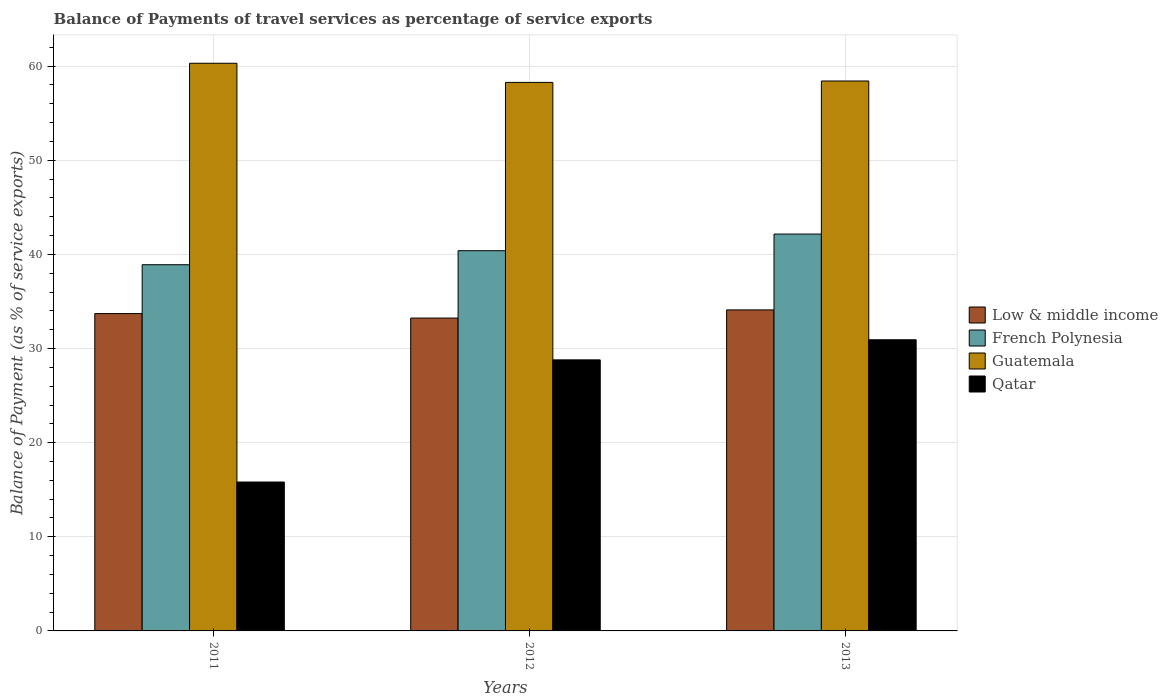How many groups of bars are there?
Provide a short and direct response. 3. How many bars are there on the 2nd tick from the left?
Offer a terse response. 4. What is the balance of payments of travel services in Guatemala in 2013?
Your response must be concise. 58.42. Across all years, what is the maximum balance of payments of travel services in Low & middle income?
Your answer should be very brief. 34.1. Across all years, what is the minimum balance of payments of travel services in Low & middle income?
Your response must be concise. 33.23. In which year was the balance of payments of travel services in Guatemala minimum?
Offer a very short reply. 2012. What is the total balance of payments of travel services in French Polynesia in the graph?
Provide a short and direct response. 121.45. What is the difference between the balance of payments of travel services in Low & middle income in 2011 and that in 2013?
Your response must be concise. -0.39. What is the difference between the balance of payments of travel services in Low & middle income in 2011 and the balance of payments of travel services in French Polynesia in 2012?
Offer a very short reply. -6.68. What is the average balance of payments of travel services in Qatar per year?
Ensure brevity in your answer.  25.18. In the year 2013, what is the difference between the balance of payments of travel services in French Polynesia and balance of payments of travel services in Low & middle income?
Your answer should be compact. 8.06. What is the ratio of the balance of payments of travel services in Qatar in 2011 to that in 2012?
Keep it short and to the point. 0.55. Is the balance of payments of travel services in Qatar in 2011 less than that in 2013?
Your answer should be compact. Yes. What is the difference between the highest and the second highest balance of payments of travel services in Qatar?
Offer a very short reply. 2.14. What is the difference between the highest and the lowest balance of payments of travel services in French Polynesia?
Ensure brevity in your answer.  3.26. In how many years, is the balance of payments of travel services in Qatar greater than the average balance of payments of travel services in Qatar taken over all years?
Your answer should be very brief. 2. Is the sum of the balance of payments of travel services in Low & middle income in 2012 and 2013 greater than the maximum balance of payments of travel services in Guatemala across all years?
Offer a terse response. Yes. What does the 1st bar from the left in 2012 represents?
Your answer should be very brief. Low & middle income. Is it the case that in every year, the sum of the balance of payments of travel services in French Polynesia and balance of payments of travel services in Qatar is greater than the balance of payments of travel services in Guatemala?
Provide a short and direct response. No. Are the values on the major ticks of Y-axis written in scientific E-notation?
Provide a short and direct response. No. Does the graph contain grids?
Provide a short and direct response. Yes. Where does the legend appear in the graph?
Your answer should be very brief. Center right. What is the title of the graph?
Make the answer very short. Balance of Payments of travel services as percentage of service exports. Does "East Asia (all income levels)" appear as one of the legend labels in the graph?
Offer a terse response. No. What is the label or title of the X-axis?
Your response must be concise. Years. What is the label or title of the Y-axis?
Make the answer very short. Balance of Payment (as % of service exports). What is the Balance of Payment (as % of service exports) in Low & middle income in 2011?
Your answer should be compact. 33.71. What is the Balance of Payment (as % of service exports) of French Polynesia in 2011?
Offer a very short reply. 38.9. What is the Balance of Payment (as % of service exports) of Guatemala in 2011?
Give a very brief answer. 60.31. What is the Balance of Payment (as % of service exports) of Qatar in 2011?
Ensure brevity in your answer.  15.82. What is the Balance of Payment (as % of service exports) of Low & middle income in 2012?
Provide a succinct answer. 33.23. What is the Balance of Payment (as % of service exports) in French Polynesia in 2012?
Provide a short and direct response. 40.39. What is the Balance of Payment (as % of service exports) of Guatemala in 2012?
Provide a succinct answer. 58.27. What is the Balance of Payment (as % of service exports) of Qatar in 2012?
Provide a succinct answer. 28.8. What is the Balance of Payment (as % of service exports) of Low & middle income in 2013?
Provide a short and direct response. 34.1. What is the Balance of Payment (as % of service exports) in French Polynesia in 2013?
Make the answer very short. 42.16. What is the Balance of Payment (as % of service exports) of Guatemala in 2013?
Offer a very short reply. 58.42. What is the Balance of Payment (as % of service exports) in Qatar in 2013?
Give a very brief answer. 30.93. Across all years, what is the maximum Balance of Payment (as % of service exports) in Low & middle income?
Provide a succinct answer. 34.1. Across all years, what is the maximum Balance of Payment (as % of service exports) of French Polynesia?
Offer a terse response. 42.16. Across all years, what is the maximum Balance of Payment (as % of service exports) of Guatemala?
Ensure brevity in your answer.  60.31. Across all years, what is the maximum Balance of Payment (as % of service exports) of Qatar?
Your answer should be very brief. 30.93. Across all years, what is the minimum Balance of Payment (as % of service exports) in Low & middle income?
Your answer should be compact. 33.23. Across all years, what is the minimum Balance of Payment (as % of service exports) in French Polynesia?
Keep it short and to the point. 38.9. Across all years, what is the minimum Balance of Payment (as % of service exports) in Guatemala?
Your response must be concise. 58.27. Across all years, what is the minimum Balance of Payment (as % of service exports) of Qatar?
Keep it short and to the point. 15.82. What is the total Balance of Payment (as % of service exports) in Low & middle income in the graph?
Your response must be concise. 101.05. What is the total Balance of Payment (as % of service exports) of French Polynesia in the graph?
Offer a very short reply. 121.45. What is the total Balance of Payment (as % of service exports) of Guatemala in the graph?
Make the answer very short. 177. What is the total Balance of Payment (as % of service exports) of Qatar in the graph?
Your answer should be compact. 75.54. What is the difference between the Balance of Payment (as % of service exports) in Low & middle income in 2011 and that in 2012?
Offer a very short reply. 0.48. What is the difference between the Balance of Payment (as % of service exports) of French Polynesia in 2011 and that in 2012?
Offer a very short reply. -1.49. What is the difference between the Balance of Payment (as % of service exports) of Guatemala in 2011 and that in 2012?
Make the answer very short. 2.03. What is the difference between the Balance of Payment (as % of service exports) of Qatar in 2011 and that in 2012?
Provide a short and direct response. -12.98. What is the difference between the Balance of Payment (as % of service exports) in Low & middle income in 2011 and that in 2013?
Give a very brief answer. -0.39. What is the difference between the Balance of Payment (as % of service exports) in French Polynesia in 2011 and that in 2013?
Your answer should be very brief. -3.26. What is the difference between the Balance of Payment (as % of service exports) of Guatemala in 2011 and that in 2013?
Your response must be concise. 1.88. What is the difference between the Balance of Payment (as % of service exports) in Qatar in 2011 and that in 2013?
Keep it short and to the point. -15.11. What is the difference between the Balance of Payment (as % of service exports) in Low & middle income in 2012 and that in 2013?
Make the answer very short. -0.87. What is the difference between the Balance of Payment (as % of service exports) in French Polynesia in 2012 and that in 2013?
Your answer should be compact. -1.77. What is the difference between the Balance of Payment (as % of service exports) of Guatemala in 2012 and that in 2013?
Offer a very short reply. -0.15. What is the difference between the Balance of Payment (as % of service exports) of Qatar in 2012 and that in 2013?
Ensure brevity in your answer.  -2.14. What is the difference between the Balance of Payment (as % of service exports) in Low & middle income in 2011 and the Balance of Payment (as % of service exports) in French Polynesia in 2012?
Offer a terse response. -6.68. What is the difference between the Balance of Payment (as % of service exports) of Low & middle income in 2011 and the Balance of Payment (as % of service exports) of Guatemala in 2012?
Your answer should be compact. -24.56. What is the difference between the Balance of Payment (as % of service exports) in Low & middle income in 2011 and the Balance of Payment (as % of service exports) in Qatar in 2012?
Ensure brevity in your answer.  4.92. What is the difference between the Balance of Payment (as % of service exports) of French Polynesia in 2011 and the Balance of Payment (as % of service exports) of Guatemala in 2012?
Make the answer very short. -19.37. What is the difference between the Balance of Payment (as % of service exports) in French Polynesia in 2011 and the Balance of Payment (as % of service exports) in Qatar in 2012?
Offer a terse response. 10.11. What is the difference between the Balance of Payment (as % of service exports) of Guatemala in 2011 and the Balance of Payment (as % of service exports) of Qatar in 2012?
Offer a very short reply. 31.51. What is the difference between the Balance of Payment (as % of service exports) of Low & middle income in 2011 and the Balance of Payment (as % of service exports) of French Polynesia in 2013?
Your answer should be compact. -8.45. What is the difference between the Balance of Payment (as % of service exports) of Low & middle income in 2011 and the Balance of Payment (as % of service exports) of Guatemala in 2013?
Your answer should be compact. -24.71. What is the difference between the Balance of Payment (as % of service exports) in Low & middle income in 2011 and the Balance of Payment (as % of service exports) in Qatar in 2013?
Make the answer very short. 2.78. What is the difference between the Balance of Payment (as % of service exports) in French Polynesia in 2011 and the Balance of Payment (as % of service exports) in Guatemala in 2013?
Offer a terse response. -19.52. What is the difference between the Balance of Payment (as % of service exports) of French Polynesia in 2011 and the Balance of Payment (as % of service exports) of Qatar in 2013?
Offer a very short reply. 7.97. What is the difference between the Balance of Payment (as % of service exports) of Guatemala in 2011 and the Balance of Payment (as % of service exports) of Qatar in 2013?
Your response must be concise. 29.37. What is the difference between the Balance of Payment (as % of service exports) in Low & middle income in 2012 and the Balance of Payment (as % of service exports) in French Polynesia in 2013?
Make the answer very short. -8.92. What is the difference between the Balance of Payment (as % of service exports) in Low & middle income in 2012 and the Balance of Payment (as % of service exports) in Guatemala in 2013?
Provide a short and direct response. -25.19. What is the difference between the Balance of Payment (as % of service exports) of Low & middle income in 2012 and the Balance of Payment (as % of service exports) of Qatar in 2013?
Your answer should be compact. 2.3. What is the difference between the Balance of Payment (as % of service exports) of French Polynesia in 2012 and the Balance of Payment (as % of service exports) of Guatemala in 2013?
Offer a terse response. -18.03. What is the difference between the Balance of Payment (as % of service exports) in French Polynesia in 2012 and the Balance of Payment (as % of service exports) in Qatar in 2013?
Keep it short and to the point. 9.46. What is the difference between the Balance of Payment (as % of service exports) in Guatemala in 2012 and the Balance of Payment (as % of service exports) in Qatar in 2013?
Keep it short and to the point. 27.34. What is the average Balance of Payment (as % of service exports) of Low & middle income per year?
Ensure brevity in your answer.  33.68. What is the average Balance of Payment (as % of service exports) of French Polynesia per year?
Give a very brief answer. 40.48. What is the average Balance of Payment (as % of service exports) in Guatemala per year?
Provide a succinct answer. 59. What is the average Balance of Payment (as % of service exports) in Qatar per year?
Provide a short and direct response. 25.18. In the year 2011, what is the difference between the Balance of Payment (as % of service exports) in Low & middle income and Balance of Payment (as % of service exports) in French Polynesia?
Provide a succinct answer. -5.19. In the year 2011, what is the difference between the Balance of Payment (as % of service exports) of Low & middle income and Balance of Payment (as % of service exports) of Guatemala?
Your answer should be compact. -26.59. In the year 2011, what is the difference between the Balance of Payment (as % of service exports) of Low & middle income and Balance of Payment (as % of service exports) of Qatar?
Ensure brevity in your answer.  17.89. In the year 2011, what is the difference between the Balance of Payment (as % of service exports) of French Polynesia and Balance of Payment (as % of service exports) of Guatemala?
Provide a succinct answer. -21.4. In the year 2011, what is the difference between the Balance of Payment (as % of service exports) of French Polynesia and Balance of Payment (as % of service exports) of Qatar?
Offer a terse response. 23.08. In the year 2011, what is the difference between the Balance of Payment (as % of service exports) in Guatemala and Balance of Payment (as % of service exports) in Qatar?
Your answer should be compact. 44.49. In the year 2012, what is the difference between the Balance of Payment (as % of service exports) in Low & middle income and Balance of Payment (as % of service exports) in French Polynesia?
Keep it short and to the point. -7.16. In the year 2012, what is the difference between the Balance of Payment (as % of service exports) in Low & middle income and Balance of Payment (as % of service exports) in Guatemala?
Your answer should be very brief. -25.04. In the year 2012, what is the difference between the Balance of Payment (as % of service exports) of Low & middle income and Balance of Payment (as % of service exports) of Qatar?
Your answer should be very brief. 4.44. In the year 2012, what is the difference between the Balance of Payment (as % of service exports) of French Polynesia and Balance of Payment (as % of service exports) of Guatemala?
Provide a succinct answer. -17.88. In the year 2012, what is the difference between the Balance of Payment (as % of service exports) of French Polynesia and Balance of Payment (as % of service exports) of Qatar?
Your answer should be compact. 11.6. In the year 2012, what is the difference between the Balance of Payment (as % of service exports) in Guatemala and Balance of Payment (as % of service exports) in Qatar?
Ensure brevity in your answer.  29.48. In the year 2013, what is the difference between the Balance of Payment (as % of service exports) of Low & middle income and Balance of Payment (as % of service exports) of French Polynesia?
Your answer should be compact. -8.06. In the year 2013, what is the difference between the Balance of Payment (as % of service exports) in Low & middle income and Balance of Payment (as % of service exports) in Guatemala?
Keep it short and to the point. -24.32. In the year 2013, what is the difference between the Balance of Payment (as % of service exports) of Low & middle income and Balance of Payment (as % of service exports) of Qatar?
Your response must be concise. 3.17. In the year 2013, what is the difference between the Balance of Payment (as % of service exports) of French Polynesia and Balance of Payment (as % of service exports) of Guatemala?
Make the answer very short. -16.26. In the year 2013, what is the difference between the Balance of Payment (as % of service exports) in French Polynesia and Balance of Payment (as % of service exports) in Qatar?
Offer a very short reply. 11.23. In the year 2013, what is the difference between the Balance of Payment (as % of service exports) in Guatemala and Balance of Payment (as % of service exports) in Qatar?
Your answer should be very brief. 27.49. What is the ratio of the Balance of Payment (as % of service exports) in Low & middle income in 2011 to that in 2012?
Your answer should be compact. 1.01. What is the ratio of the Balance of Payment (as % of service exports) of French Polynesia in 2011 to that in 2012?
Your answer should be compact. 0.96. What is the ratio of the Balance of Payment (as % of service exports) of Guatemala in 2011 to that in 2012?
Your answer should be very brief. 1.03. What is the ratio of the Balance of Payment (as % of service exports) of Qatar in 2011 to that in 2012?
Make the answer very short. 0.55. What is the ratio of the Balance of Payment (as % of service exports) in French Polynesia in 2011 to that in 2013?
Keep it short and to the point. 0.92. What is the ratio of the Balance of Payment (as % of service exports) of Guatemala in 2011 to that in 2013?
Give a very brief answer. 1.03. What is the ratio of the Balance of Payment (as % of service exports) of Qatar in 2011 to that in 2013?
Make the answer very short. 0.51. What is the ratio of the Balance of Payment (as % of service exports) of Low & middle income in 2012 to that in 2013?
Make the answer very short. 0.97. What is the ratio of the Balance of Payment (as % of service exports) of French Polynesia in 2012 to that in 2013?
Your answer should be very brief. 0.96. What is the ratio of the Balance of Payment (as % of service exports) of Qatar in 2012 to that in 2013?
Your answer should be compact. 0.93. What is the difference between the highest and the second highest Balance of Payment (as % of service exports) in Low & middle income?
Offer a terse response. 0.39. What is the difference between the highest and the second highest Balance of Payment (as % of service exports) in French Polynesia?
Offer a terse response. 1.77. What is the difference between the highest and the second highest Balance of Payment (as % of service exports) of Guatemala?
Your answer should be compact. 1.88. What is the difference between the highest and the second highest Balance of Payment (as % of service exports) of Qatar?
Keep it short and to the point. 2.14. What is the difference between the highest and the lowest Balance of Payment (as % of service exports) in Low & middle income?
Provide a short and direct response. 0.87. What is the difference between the highest and the lowest Balance of Payment (as % of service exports) of French Polynesia?
Your answer should be compact. 3.26. What is the difference between the highest and the lowest Balance of Payment (as % of service exports) of Guatemala?
Your answer should be very brief. 2.03. What is the difference between the highest and the lowest Balance of Payment (as % of service exports) of Qatar?
Keep it short and to the point. 15.11. 